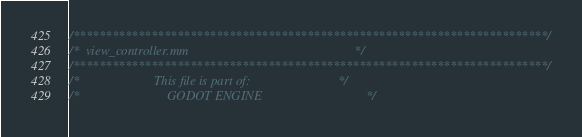<code> <loc_0><loc_0><loc_500><loc_500><_ObjectiveC_>/*************************************************************************/
/*  view_controller.mm                                                   */
/*************************************************************************/
/*                       This file is part of:                           */
/*                           GODOT ENGINE                                */</code> 